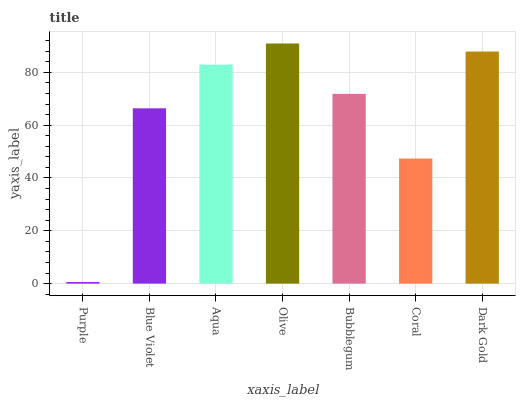Is Purple the minimum?
Answer yes or no. Yes. Is Olive the maximum?
Answer yes or no. Yes. Is Blue Violet the minimum?
Answer yes or no. No. Is Blue Violet the maximum?
Answer yes or no. No. Is Blue Violet greater than Purple?
Answer yes or no. Yes. Is Purple less than Blue Violet?
Answer yes or no. Yes. Is Purple greater than Blue Violet?
Answer yes or no. No. Is Blue Violet less than Purple?
Answer yes or no. No. Is Bubblegum the high median?
Answer yes or no. Yes. Is Bubblegum the low median?
Answer yes or no. Yes. Is Coral the high median?
Answer yes or no. No. Is Purple the low median?
Answer yes or no. No. 